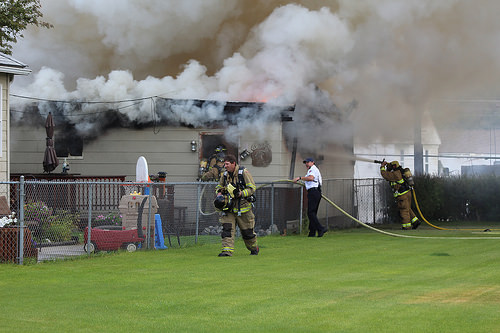<image>
Can you confirm if the smoke is above the grass? Yes. The smoke is positioned above the grass in the vertical space, higher up in the scene. Is the smoke above the lawn? Yes. The smoke is positioned above the lawn in the vertical space, higher up in the scene. 